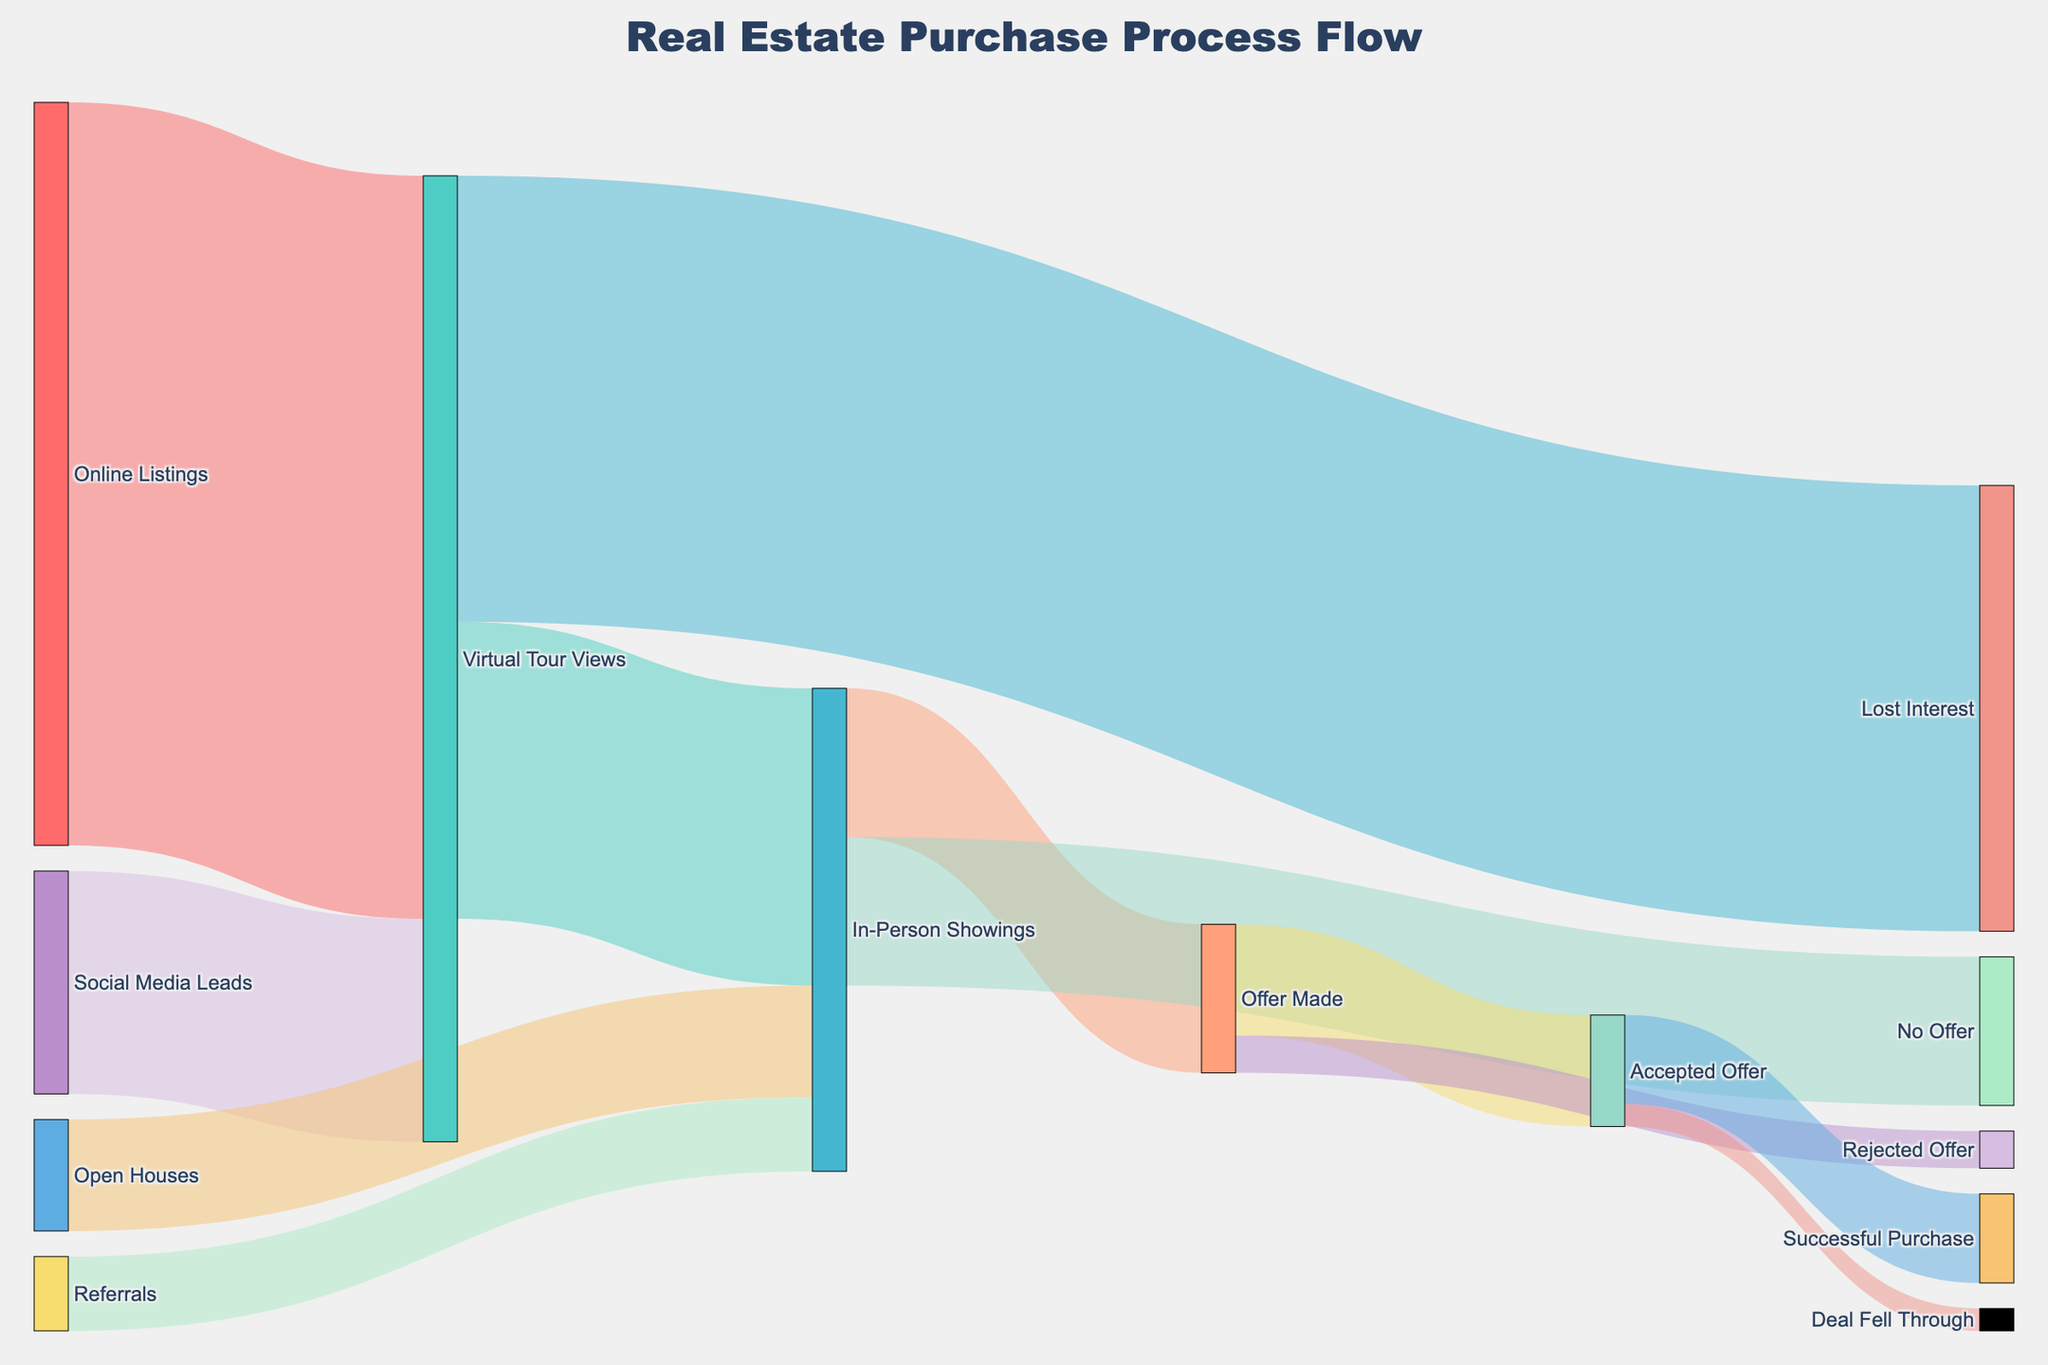How many potential buyers viewed virtual tours according to the diagram? The diagram shows an arrow from "Online Listings" to "Virtual Tour Views" with a value of 1000.
Answer: 1000 What is the number of potential buyers who showed interest through referrals and attended in-person showings? The diagram shows an arrow from "Referrals" to "In-Person Showings" with a value of 100.
Answer: 100 Which stage had more people lose interest: virtual tours or in-person showings? Comparing the stages, the diagram shows 600 losing interest after virtual tours, and there is no direct "lose interest" segment for in-person showings, therefore, virtual tours have more.
Answer: Virtual tours How many potential buyers made offers after in-person showings? The diagram shows an arrow from "In-Person Showings" to "Offer Made" with a value of 200.
Answer: 200 Out of the offers made, how many were accepted? The diagram shows an arrow from "Offer Made" to "Accepted Offer" with a value of 150.
Answer: 150 How many buyers progressed from accepted offers to successful purchases? The diagram shows an arrow from "Accepted Offer" to "Successful Purchase" with a value of 120.
Answer: 120 What is the difference between the number of buyers who lost interest and those who did not make an offer after in-person showings? The diagram shows 600 lost interest after virtual tours and 200 did not make an offer after in-person showings. The difference is 600 - 200.
Answer: 400 What percentage of those who viewed virtual tours ended up making an offer? Out of the 1000 who viewed virtual tours, 200 made an offer. The percentage is (200/1000) * 100%.
Answer: 20% Which lead source contributed more to in-person showings: referrals or open houses? Comparing the arrows, "Referrals" to "In-Person Showings" has a value of 100, and "Open Houses" to "In-Person Showings" has a value of 150. Therefore, open houses contributed more.
Answer: Open houses How many individuals faced a deal falling through after an accepted offer? The diagram shows an arrow from "Accepted Offer" to "Deal Fell Through" with a value of 30.
Answer: 30 